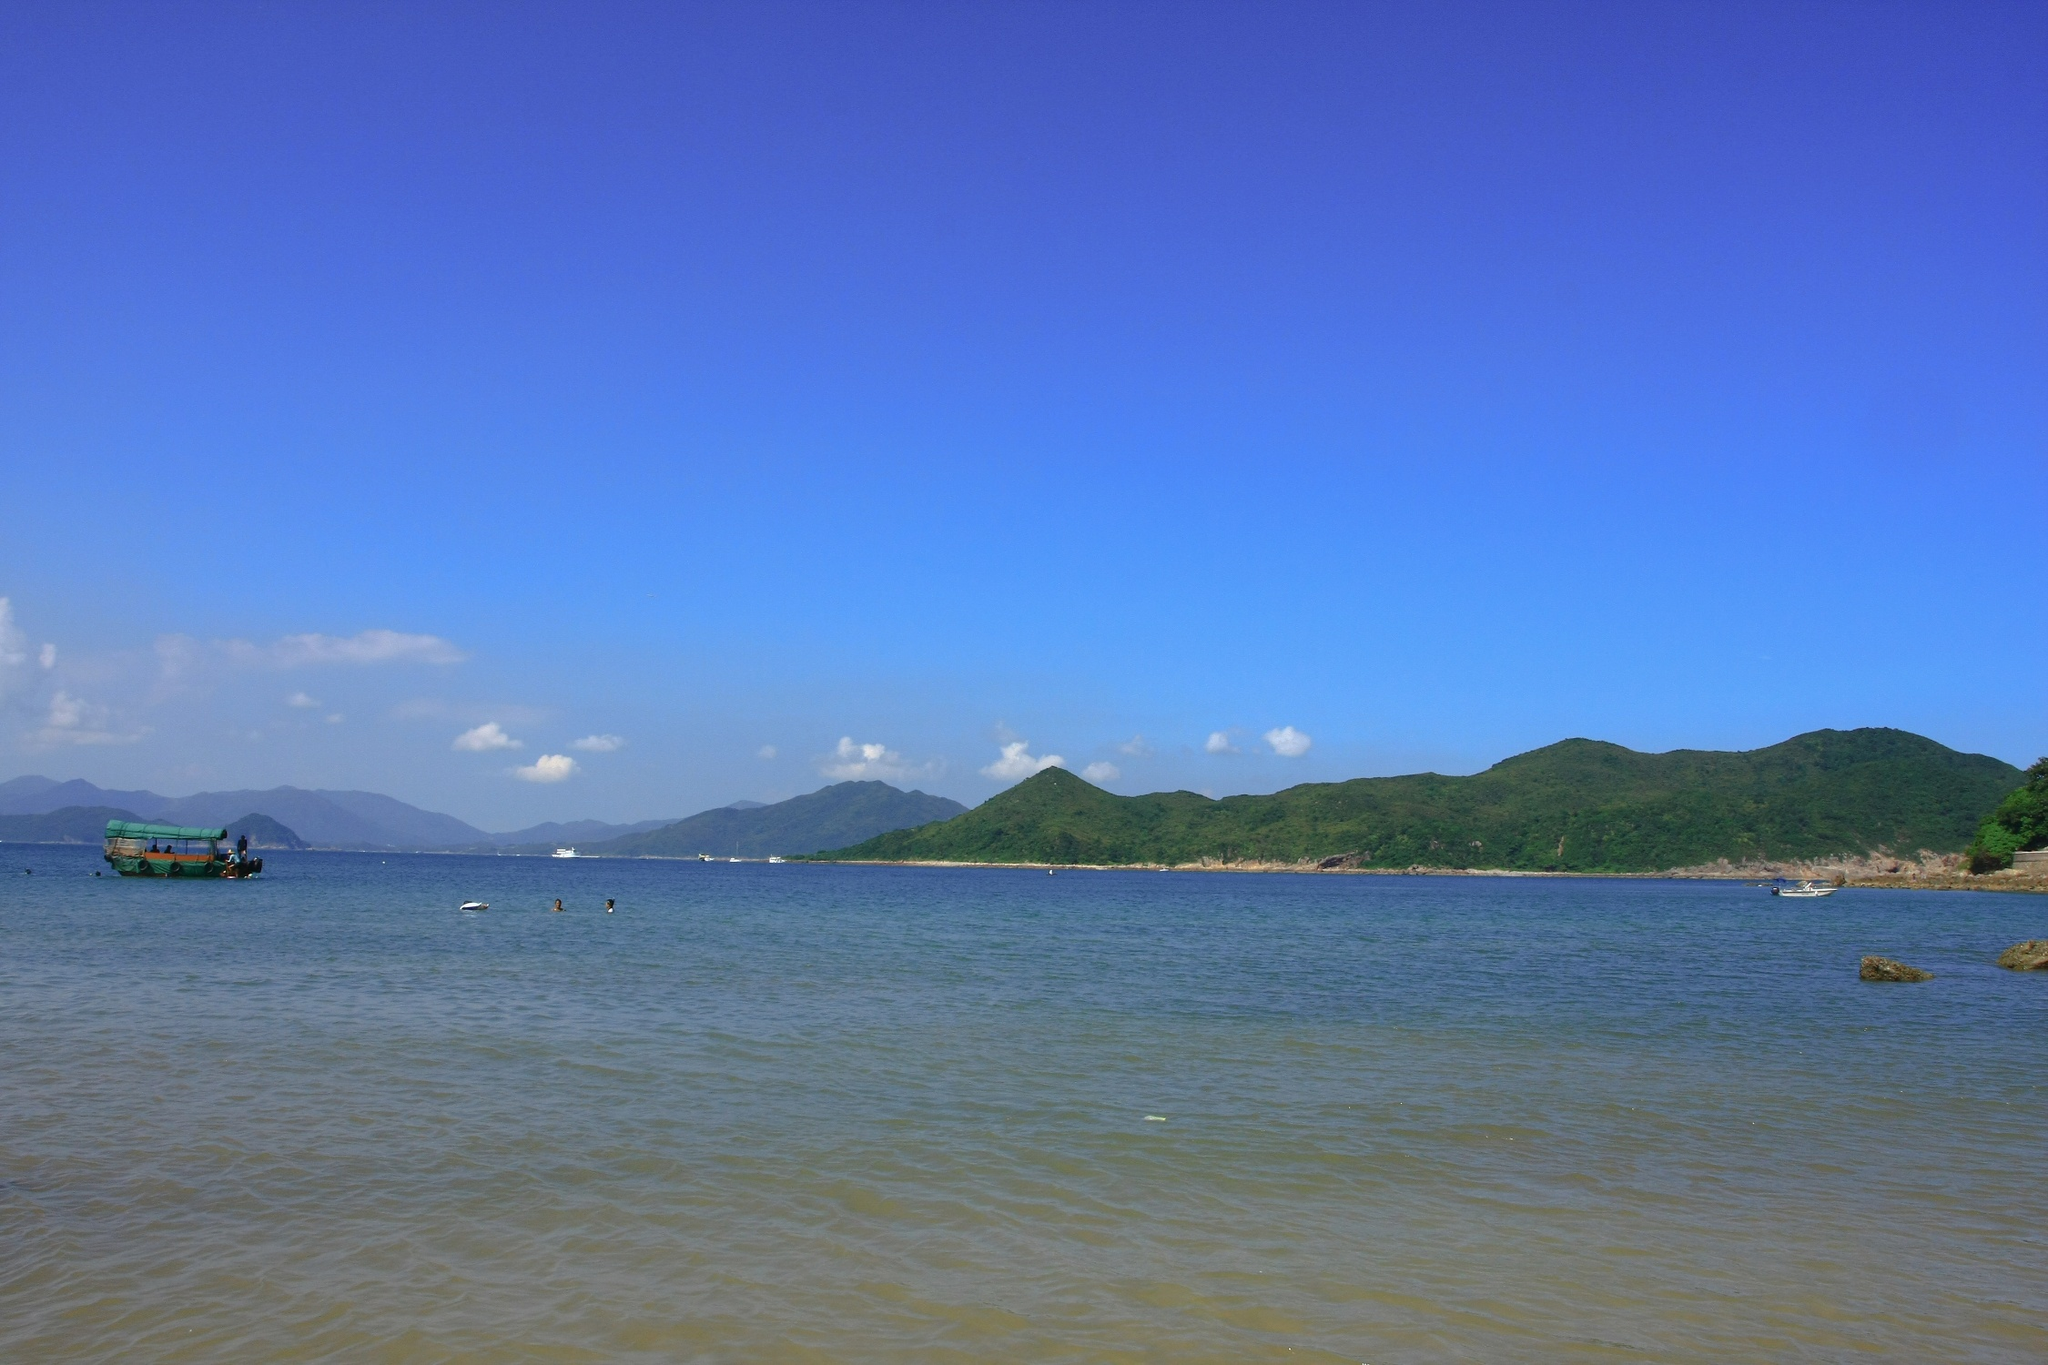If this scene were to come alive, what sounds or scents might one experience? If the scene were to come alive, one would likely hear the gentle lapping of waves against the shoreline, the distant call of seabirds soaring overhead, and the soft hum of the boat's motor. The salty scent of the ocean would mingle with the fresh, earthy aroma of the nearby greenery. Occasionally, a light breeze might carry the faint scent of seaweed or the far-off, tantalizing hint of grilling fish from a coastal village. What kind of marine life might be found in these waters? These waters could be home to a diverse range of marine life. One might find schools of colorful fish darting through the shallows, crabs scuttling along the sandy bottom, and various species of shellfish like clams and mussels. In deeper areas, larger fish such as tuna or mackerel might be more common. Dolphins could occasionally be seen playing in the distance, and it's possible that further out, larger marine animals like whales might pass through during their migrations. Imagine this place during a storm. How would the scene change? During a storm, this serene scene would transform dramatically. The calm, clear waters would become choppy and turbulent, with waves crashing energetically against the shore. The bright blue sky would turn dark and ominous, heavy with thick, swirling storm clouds. Rain would lash down, and the wind would howl through the air, creating a symphony of chaotic natural sounds. The previously visible mountains might become shrouded in mist and rain, adding to the drama of the scene. The small green boat would either be anchored securely, riding out the storm as it bobbed up and down on the waves, or it might have sought refuge in a sheltered inlet. What mythical creatures would fit perfectly into this scene? In this picturesque coastal scene, one might imagine mythical creatures like mermaids with shimmering tails swimming gracefully near the boat, their hauntingly beautiful songs blending with the sounds of the waves. Beneath the surface, sea serpents could be gliding silently through the deeper waters, their scales glistening in the sunlight filtering down from above. Near the shore, water sprites might playfully dance on the waves, their laughter ringing out in the salty air. On the rocky outcrops, perhaps a wise, old kraken rests, its massive tentacles occasionally breaking the surface as it basks in the warmth of the sun. 